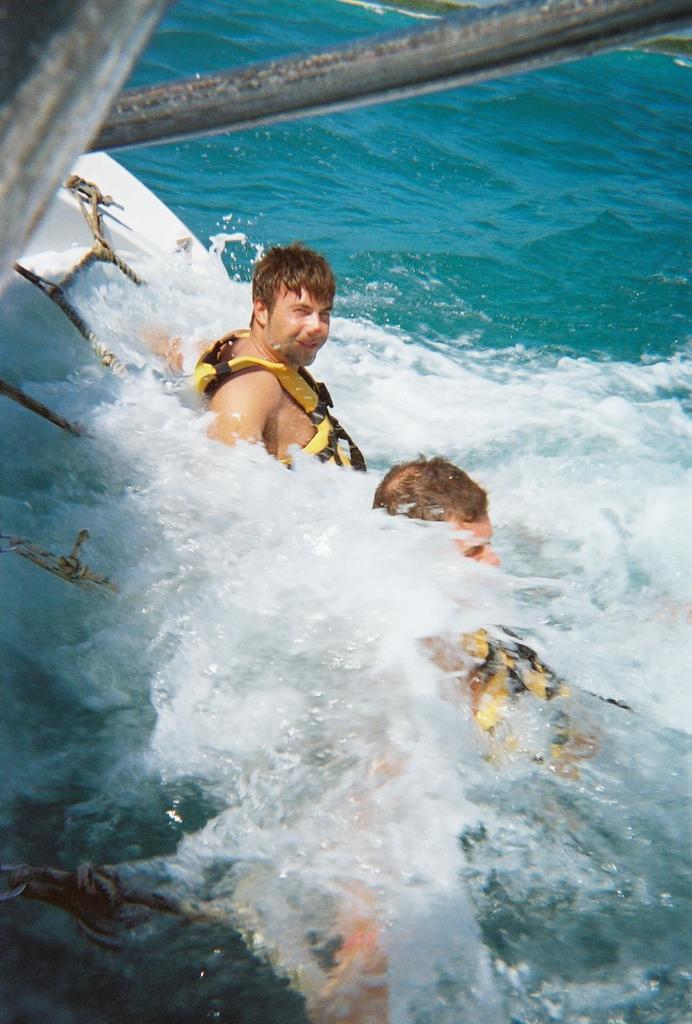Can you describe this image briefly? In this image, I can see two persons in the water. On the left side of the image, I can see a rope net. At the top of the image, these are looking like the iron rods. 